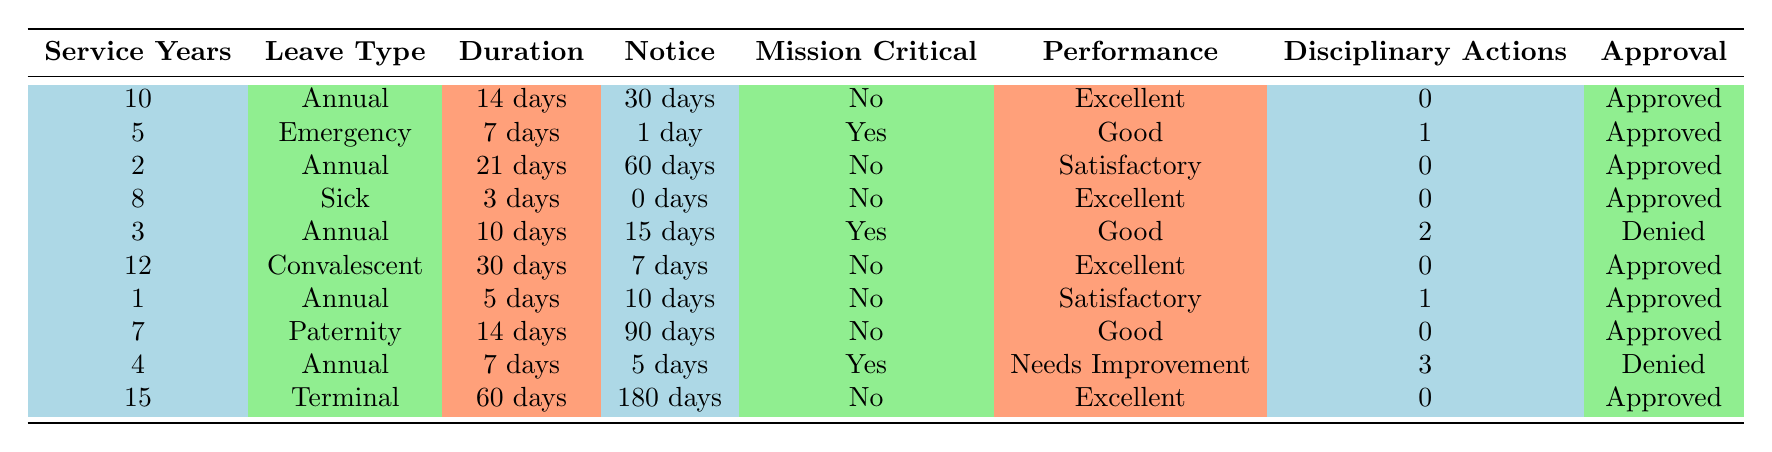What's the approval status for a leave request with 10 service years? The row in the table for 10 service years indicates that the leave type is "Annual," the request duration is "14 days," notice given is "30 days," and the approval status is "Approved."
Answer: Approved How many disciplinary actions are associated with the request for 14 days of paternity leave? Looking at the row for paternity leave, it shows that there were "0" disciplinary actions linked to the request for 14 days.
Answer: 0 Is there any leave request for more than 20 days? By reviewing the requests, only one leave request is for more than 20 days, which is the "Annual" leave for "21 days" associated with 2 service years. However, since it's specified that multiple rows need to be checked, we confirm that it applies to only one entry.
Answer: Yes What are the performance ratings for leave requests that were denied? There are two leave requests marked as denied (one for 10 days with 3 disciplinary actions and performance rated as "Needs Improvement," and another for 7 days with 2 disciplinary actions rated as "Good"). So, the performance ratings for denied requests are "Needs Improvement" and "Good."
Answer: Needs Improvement and Good What is the average duration of approved leave requests? To calculate the average, sum the durations of all approved leave requests: 14 + 7 + 21 + 3 + 30 + 5 + 14 + 60 = 154 days. There are 8 approved requests, so the average is 154 / 8 = 19.25 days.
Answer: 19.25 days Does a leave request for emergency leave require a minimum notice period? The emergency leave request shown in the table had "1 day" notice given. Therefore, it implies emergency leave can be approved with short notice.
Answer: Yes Which leave type had the longest approval duration and what was its notice requirement? The longest approval duration is for "Terminal" leave, which is "60 days," and it required a notice of "180 days." This indicates a longer planning period is needed for this type of leave.
Answer: Terminal leave, 60 days, 180 days notice Is an annual leave request denied if the performance rating is satisfactory? The annual leave request with "3 service years," performance rated as "Good," was denied along with one with a performance of "Needs Improvement." Therefore, the satisfactory rating does not guarantee approval as shown.
Answer: Yes 